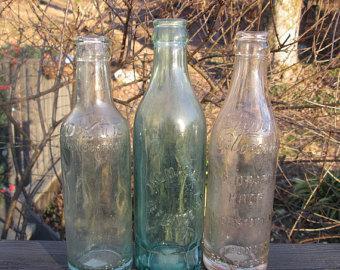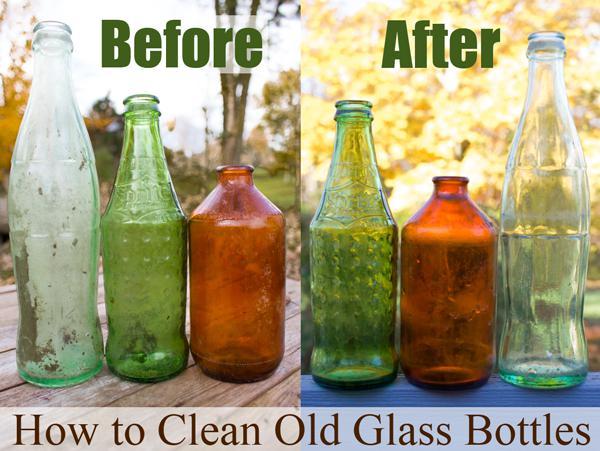The first image is the image on the left, the second image is the image on the right. Considering the images on both sides, is "There are at most 3 bottles in the image pair." valid? Answer yes or no. No. The first image is the image on the left, the second image is the image on the right. Assess this claim about the two images: "There are three glass bottles in the left image.". Correct or not? Answer yes or no. Yes. 